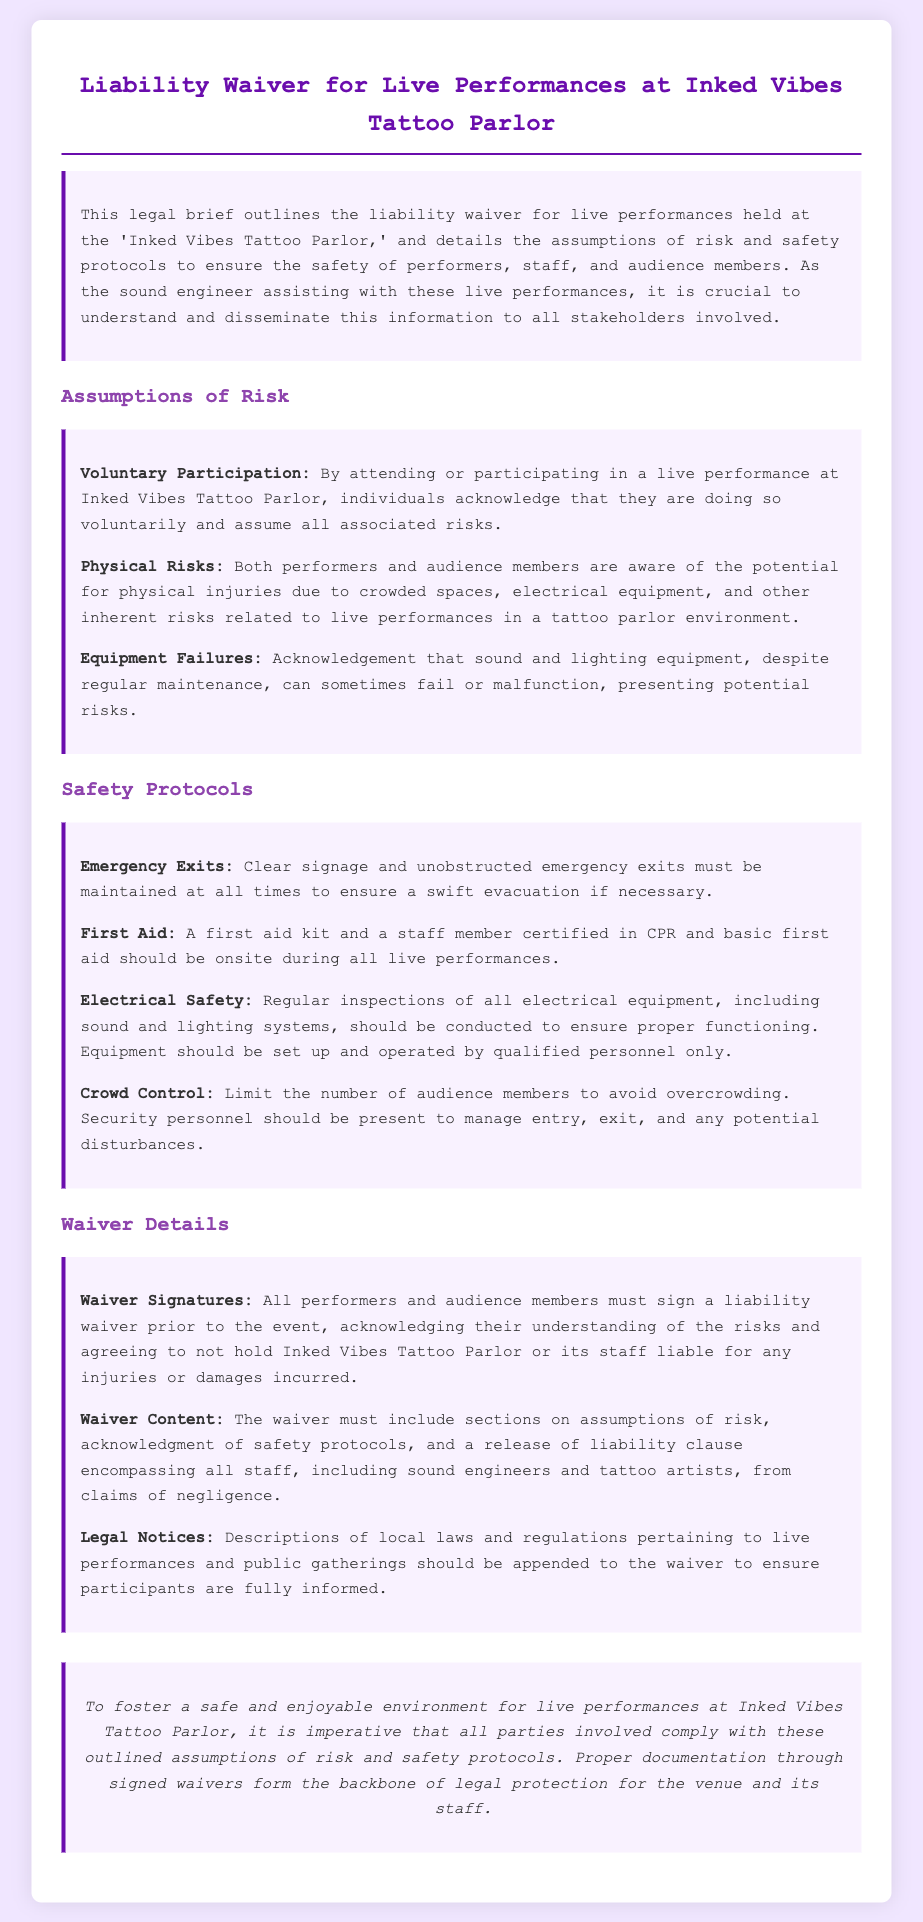what is the title of the document? The title of the document is presented prominently at the top, indicating its subject matter regarding liability waivers.
Answer: Liability Waiver for Live Performances at Inked Vibes Tattoo Parlor what must all performers and audience members do before the event? The document specifies that performers and audience members are required to sign a liability waiver prior to attending the event.
Answer: Sign a liability waiver what type of safety equipment must be on-site during live performances? The document mentions that a first aid kit and a certified staff member must be present during performances for safety.
Answer: First aid kit who should manage entry and exit to avoid overcrowding? The document states that security personnel should be responsible for managing audience entry, exit, and disturbances.
Answer: Security personnel what do individuals acknowledge by participating in the performance? Participation in the performance involves an acknowledgment of voluntary participation and the assumption of risks involved.
Answer: Assume all associated risks how should electrical equipment be managed according to the safety protocols? The safety protocols specify that electrical equipment must be inspected regularly to ensure safety and proper functioning.
Answer: Regular inspections what does the waiver content include? The waiver content must comprise multiple sections, including assumptions of risk, safety protocols acknowledgment, and a release of liability clause.
Answer: Assumptions of risk, acknowledgment of safety protocols, release of liability clause how are emergency exits to be maintained? The document emphasizes that emergency exits should have clear signage and remain unobstructed at all times.
Answer: Clear signage and unobstructed what should be included in the legal notices appended to the waiver? Legal notices should provide details on local laws and regulations concerning live performances and public gatherings.
Answer: Local laws and regulations what is a key purpose of the waiver? The waiver serves as a legal protection measure for the venue and its staff against claims of negligence.
Answer: Legal protection for the venue and staff 